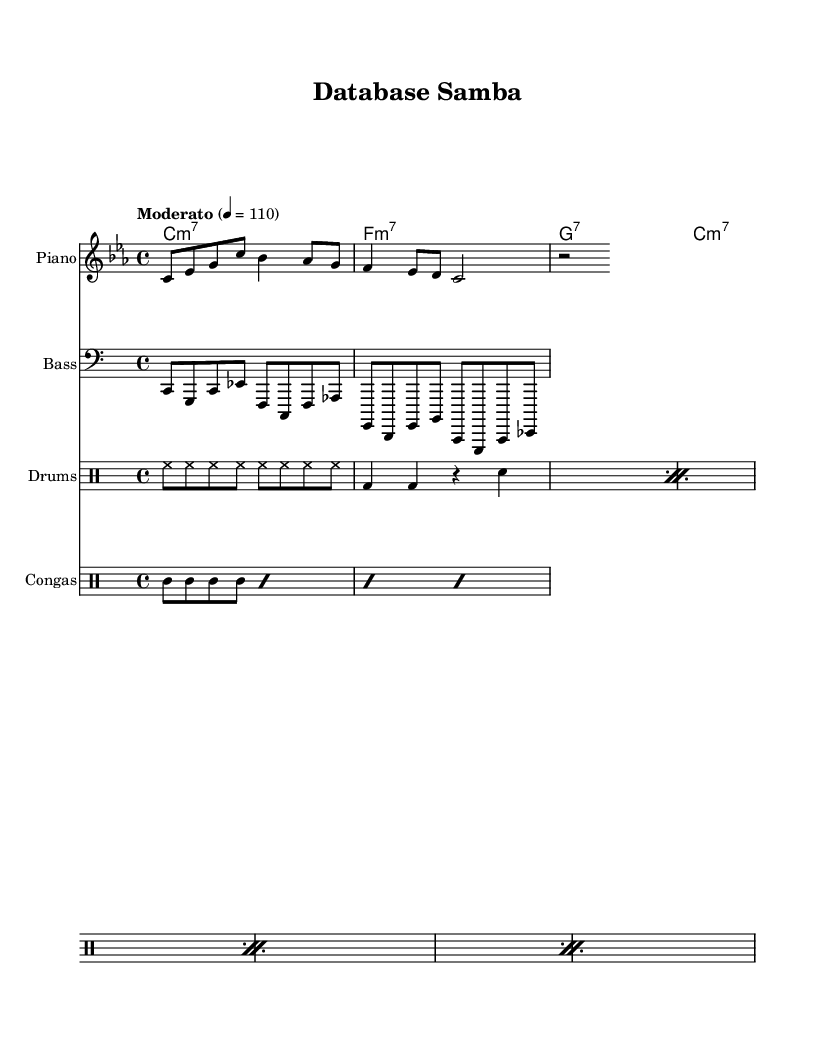What is the key signature of this music? The key signature is indicated once at the beginning of the staff. It shows three flats, which correlates to the key of C minor.
Answer: C minor What is the time signature of this piece? The time signature is indicated at the beginning of the staff. It shows a "4/4" marking, meaning there are four beats in each measure and the quarter note gets one beat.
Answer: 4/4 What is the tempo marking for this piece? The tempo marking is given at the start of the score. It states "Moderato" with a metronome indication of "4 = 110", which means the piece should be played moderately at 110 beats per minute.
Answer: Moderato 4 = 110 How many measures are in the melody? The melody is a part of the score that can be counted measure by measure. There are a total of four measures present in the melody section.
Answer: 4 What type of chords are used in the harmony section? The harmony section shows the chord symbols placed above the staff. They indicate that the chords are predominantly minor seventh chords (denoted as "m7") and one dominant seventh chord (denoted as "7").
Answer: Minor seventh and dominant seventh What rhythmic figure is commonly used for the congas? The conga part is defined by repeated rhythmic patterns each surrounded by "cgh" and "cgl" notes, which creates a clave-like rhythm commonly used in Latin jazz.
Answer: Clave rhythm What instruments are included in this score? The score lists several staves, and by examining the labels, we can identify the instruments present: Piano, Bass, Drums, and Congas.
Answer: Piano, Bass, Drums, Congas 